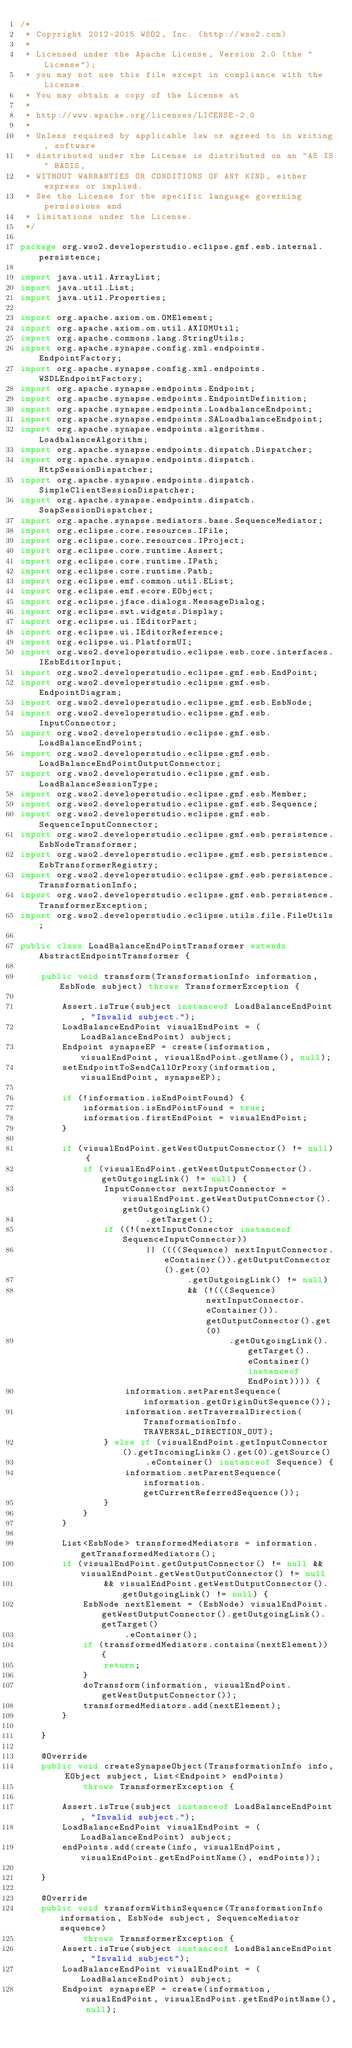Convert code to text. <code><loc_0><loc_0><loc_500><loc_500><_Java_>/*
 * Copyright 2012-2015 WSO2, Inc. (http://wso2.com)
 *
 * Licensed under the Apache License, Version 2.0 (the "License");
 * you may not use this file except in compliance with the License.
 * You may obtain a copy of the License at
 *
 * http://www.apache.org/licenses/LICENSE-2.0
 *
 * Unless required by applicable law or agreed to in writing, software
 * distributed under the License is distributed on an "AS IS" BASIS,
 * WITHOUT WARRANTIES OR CONDITIONS OF ANY KIND, either express or implied.
 * See the License for the specific language governing permissions and
 * limitations under the License.
 */

package org.wso2.developerstudio.eclipse.gmf.esb.internal.persistence;

import java.util.ArrayList;
import java.util.List;
import java.util.Properties;

import org.apache.axiom.om.OMElement;
import org.apache.axiom.om.util.AXIOMUtil;
import org.apache.commons.lang.StringUtils;
import org.apache.synapse.config.xml.endpoints.EndpointFactory;
import org.apache.synapse.config.xml.endpoints.WSDLEndpointFactory;
import org.apache.synapse.endpoints.Endpoint;
import org.apache.synapse.endpoints.EndpointDefinition;
import org.apache.synapse.endpoints.LoadbalanceEndpoint;
import org.apache.synapse.endpoints.SALoadbalanceEndpoint;
import org.apache.synapse.endpoints.algorithms.LoadbalanceAlgorithm;
import org.apache.synapse.endpoints.dispatch.Dispatcher;
import org.apache.synapse.endpoints.dispatch.HttpSessionDispatcher;
import org.apache.synapse.endpoints.dispatch.SimpleClientSessionDispatcher;
import org.apache.synapse.endpoints.dispatch.SoapSessionDispatcher;
import org.apache.synapse.mediators.base.SequenceMediator;
import org.eclipse.core.resources.IFile;
import org.eclipse.core.resources.IProject;
import org.eclipse.core.runtime.Assert;
import org.eclipse.core.runtime.IPath;
import org.eclipse.core.runtime.Path;
import org.eclipse.emf.common.util.EList;
import org.eclipse.emf.ecore.EObject;
import org.eclipse.jface.dialogs.MessageDialog;
import org.eclipse.swt.widgets.Display;
import org.eclipse.ui.IEditorPart;
import org.eclipse.ui.IEditorReference;
import org.eclipse.ui.PlatformUI;
import org.wso2.developerstudio.eclipse.esb.core.interfaces.IEsbEditorInput;
import org.wso2.developerstudio.eclipse.gmf.esb.EndPoint;
import org.wso2.developerstudio.eclipse.gmf.esb.EndpointDiagram;
import org.wso2.developerstudio.eclipse.gmf.esb.EsbNode;
import org.wso2.developerstudio.eclipse.gmf.esb.InputConnector;
import org.wso2.developerstudio.eclipse.gmf.esb.LoadBalanceEndPoint;
import org.wso2.developerstudio.eclipse.gmf.esb.LoadBalanceEndPointOutputConnector;
import org.wso2.developerstudio.eclipse.gmf.esb.LoadBalanceSessionType;
import org.wso2.developerstudio.eclipse.gmf.esb.Member;
import org.wso2.developerstudio.eclipse.gmf.esb.Sequence;
import org.wso2.developerstudio.eclipse.gmf.esb.SequenceInputConnector;
import org.wso2.developerstudio.eclipse.gmf.esb.persistence.EsbNodeTransformer;
import org.wso2.developerstudio.eclipse.gmf.esb.persistence.EsbTransformerRegistry;
import org.wso2.developerstudio.eclipse.gmf.esb.persistence.TransformationInfo;
import org.wso2.developerstudio.eclipse.gmf.esb.persistence.TransformerException;
import org.wso2.developerstudio.eclipse.utils.file.FileUtils;

public class LoadBalanceEndPointTransformer extends AbstractEndpointTransformer {

    public void transform(TransformationInfo information, EsbNode subject) throws TransformerException {

        Assert.isTrue(subject instanceof LoadBalanceEndPoint, "Invalid subject.");
        LoadBalanceEndPoint visualEndPoint = (LoadBalanceEndPoint) subject;
        Endpoint synapseEP = create(information, visualEndPoint, visualEndPoint.getName(), null);
        setEndpointToSendCallOrProxy(information, visualEndPoint, synapseEP);

        if (!information.isEndPointFound) {
            information.isEndPointFound = true;
            information.firstEndPoint = visualEndPoint;
        }

        if (visualEndPoint.getWestOutputConnector() != null) {
            if (visualEndPoint.getWestOutputConnector().getOutgoingLink() != null) {
                InputConnector nextInputConnector = visualEndPoint.getWestOutputConnector().getOutgoingLink()
                        .getTarget();
                if ((!(nextInputConnector instanceof SequenceInputConnector))
                        || ((((Sequence) nextInputConnector.eContainer()).getOutputConnector().get(0)
                                .getOutgoingLink() != null)
                                && (!(((Sequence) nextInputConnector.eContainer()).getOutputConnector().get(0)
                                        .getOutgoingLink().getTarget().eContainer() instanceof EndPoint)))) {
                    information.setParentSequence(information.getOriginOutSequence());
                    information.setTraversalDirection(TransformationInfo.TRAVERSAL_DIRECTION_OUT);
                } else if (visualEndPoint.getInputConnector().getIncomingLinks().get(0).getSource()
                        .eContainer() instanceof Sequence) {
                    information.setParentSequence(information.getCurrentReferredSequence());
                }
            }
        }

        List<EsbNode> transformedMediators = information.getTransformedMediators();
        if (visualEndPoint.getOutputConnector() != null && visualEndPoint.getWestOutputConnector() != null
                && visualEndPoint.getWestOutputConnector().getOutgoingLink() != null) {
            EsbNode nextElement = (EsbNode) visualEndPoint.getWestOutputConnector().getOutgoingLink().getTarget()
                    .eContainer();
            if (transformedMediators.contains(nextElement)) {
                return;
            }
            doTransform(information, visualEndPoint.getWestOutputConnector());
            transformedMediators.add(nextElement);
        }

    }

    @Override
    public void createSynapseObject(TransformationInfo info, EObject subject, List<Endpoint> endPoints)
            throws TransformerException {

        Assert.isTrue(subject instanceof LoadBalanceEndPoint, "Invalid subject.");
        LoadBalanceEndPoint visualEndPoint = (LoadBalanceEndPoint) subject;
        endPoints.add(create(info, visualEndPoint, visualEndPoint.getEndPointName(), endPoints));

    }

    @Override
    public void transformWithinSequence(TransformationInfo information, EsbNode subject, SequenceMediator sequence)
            throws TransformerException {
        Assert.isTrue(subject instanceof LoadBalanceEndPoint, "Invalid subject");
        LoadBalanceEndPoint visualEndPoint = (LoadBalanceEndPoint) subject;
        Endpoint synapseEP = create(information, visualEndPoint, visualEndPoint.getEndPointName(), null);</code> 